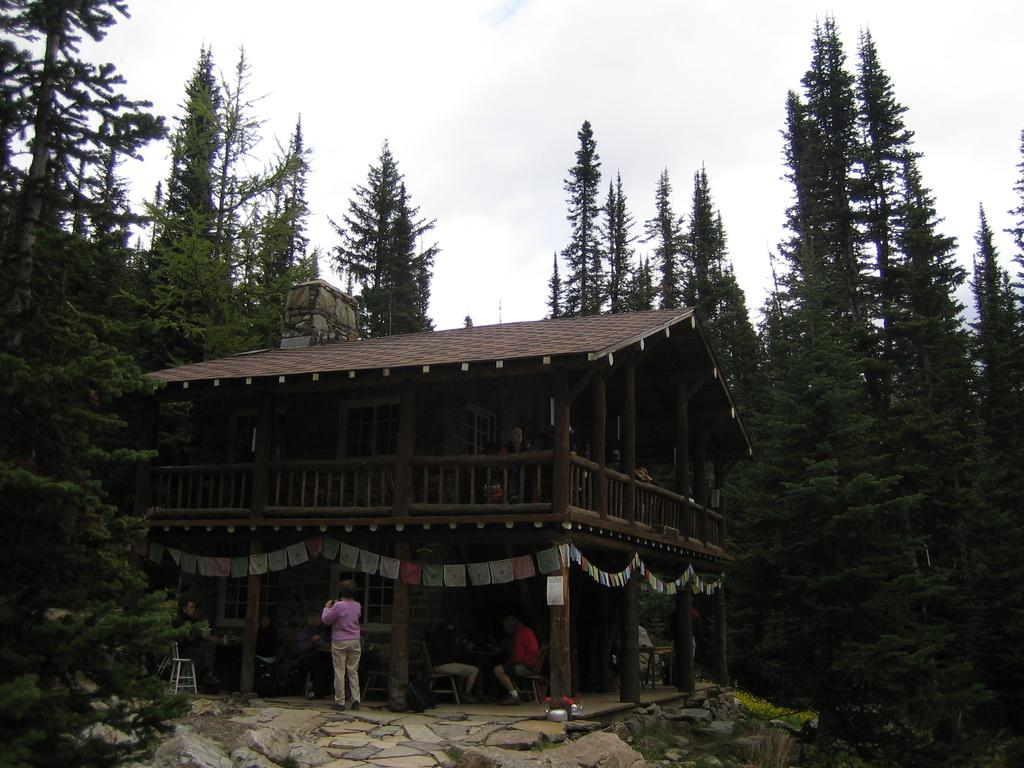What is the main subject in the center of the image? There is a house in the center of the image. What are the people in the image doing? The people are sitting on chairs. What can be seen in the background of the image? There are trees and sky visible in the background of the image. What is located in front of the image? There are rocks in front of the image. What type of plastic material can be seen covering the trees in the image? There is no plastic material covering the trees in the image. 